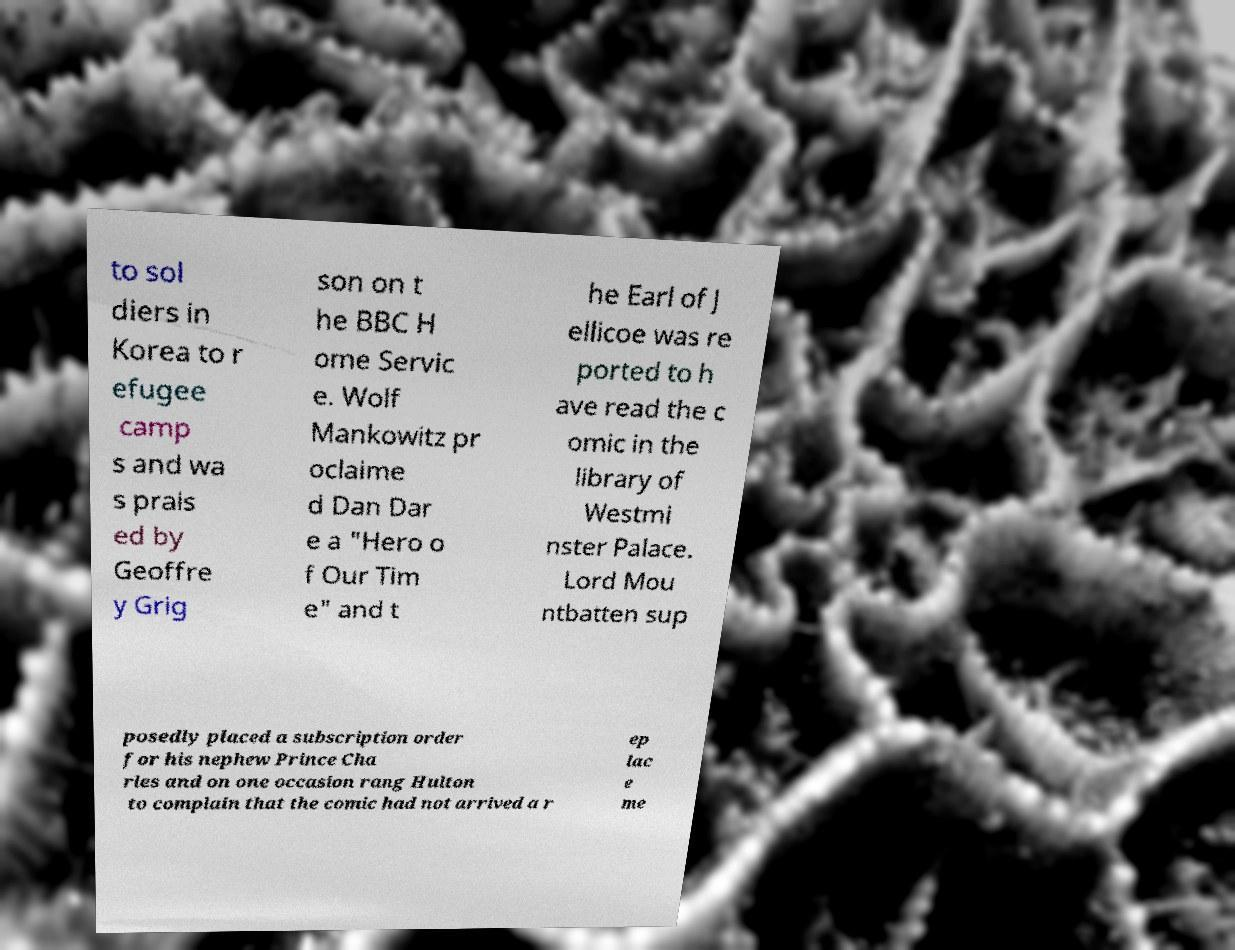I need the written content from this picture converted into text. Can you do that? to sol diers in Korea to r efugee camp s and wa s prais ed by Geoffre y Grig son on t he BBC H ome Servic e. Wolf Mankowitz pr oclaime d Dan Dar e a "Hero o f Our Tim e" and t he Earl of J ellicoe was re ported to h ave read the c omic in the library of Westmi nster Palace. Lord Mou ntbatten sup posedly placed a subscription order for his nephew Prince Cha rles and on one occasion rang Hulton to complain that the comic had not arrived a r ep lac e me 